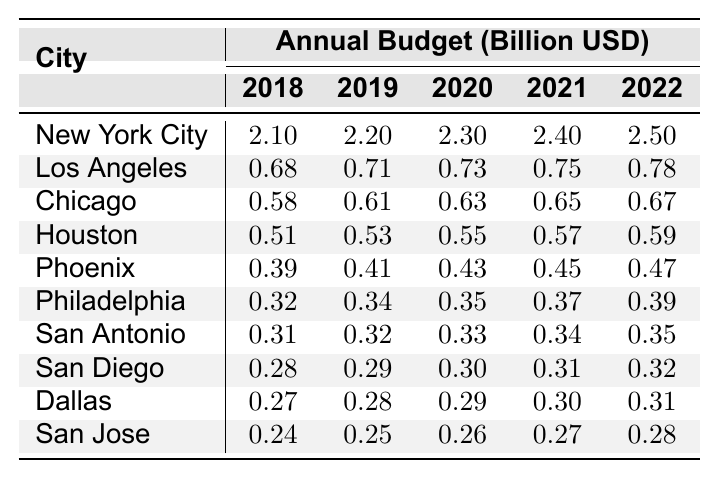What was the budget allocation for New York City in 2022? Referring to the table, the budget allocation for New York City in 2022 is directly listed as 2.50 billion USD.
Answer: 2.50 billion USD Which city had the lowest budget allocation in 2018? From the table, we see that San Jose had the lowest budget allocation in 2018, which is 0.24 billion USD.
Answer: San Jose What is the average budget allocation for Los Angeles from 2018 to 2022? To find the average, we add the budget allocations for Los Angeles from each year: 0.68 + 0.71 + 0.73 + 0.75 + 0.78 = 3.65. There are 5 years, so the average is 3.65 / 5 = 0.73 billion USD.
Answer: 0.73 billion USD Did any city have a consistent increase in budget allocation from 2018 to 2022? Checking the table, we see that New York City consistently increased its budget allocation from 2.10 billion USD in 2018 to 2.50 billion USD in 2022, indicating a consistent increase.
Answer: Yes What is the cumulative budget allocation for Houston from 2018 to 2022? The cumulative budget allocation for Houston is calculated by summing the values: 0.51 + 0.53 + 0.55 + 0.57 + 0.59 = 2.75 billion USD.
Answer: 2.75 billion USD Which city had the highest budget allocation in 2021, and what was the amount? Looking at the table for 2021, New York City had the highest budget of 2.40 billion USD.
Answer: New York City, 2.40 billion USD What is the total budget allocation for all cities in 2022? To find the total for 2022, we sum all the budget allocations: 2.50 + 0.78 + 0.67 + 0.59 + 0.47 + 0.39 + 0.35 + 0.32 + 0.31 + 0.28 = 6.48 billion USD.
Answer: 6.48 billion USD From which year to which year did Philadelphia see the largest percentage increase in budget allocation? The budget allocation for Philadelphia from 2018 to 2022 increases from 0.32 to 0.39 billion USD. The percentage increase is ((0.39 - 0.32) / 0.32) * 100 = 21.88%, which is the largest change for this city.
Answer: 2018 to 2022 Is the budget allocation for San Diego higher than that of Dallas in all years? By comparing the values in the table, San Diego's allocation is consistently higher than Dallas's in all years. San Diego has 0.28, 0.29, 0.30, 0.31, and 0.32 billion USD compared to Dallas's 0.27, 0.28, 0.29, 0.30, and 0.31 billion USD.
Answer: Yes What is the difference in budget allocation between the highest and the lowest budget cities in 2022? In 2022, New York City had 2.50 billion USD and San Jose had 0.28 billion USD. The difference is 2.50 - 0.28 = 2.22 billion USD.
Answer: 2.22 billion USD 